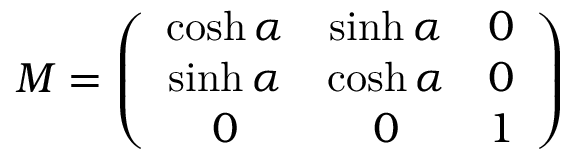<formula> <loc_0><loc_0><loc_500><loc_500>M = \left ( \begin{array} { c c c } { \cosh \alpha } & { \sinh \alpha } & { 0 } \\ { \sinh \alpha } & { \cosh \alpha } & { 0 } \\ { 0 } & { 0 } & { 1 } \end{array} \right )</formula> 